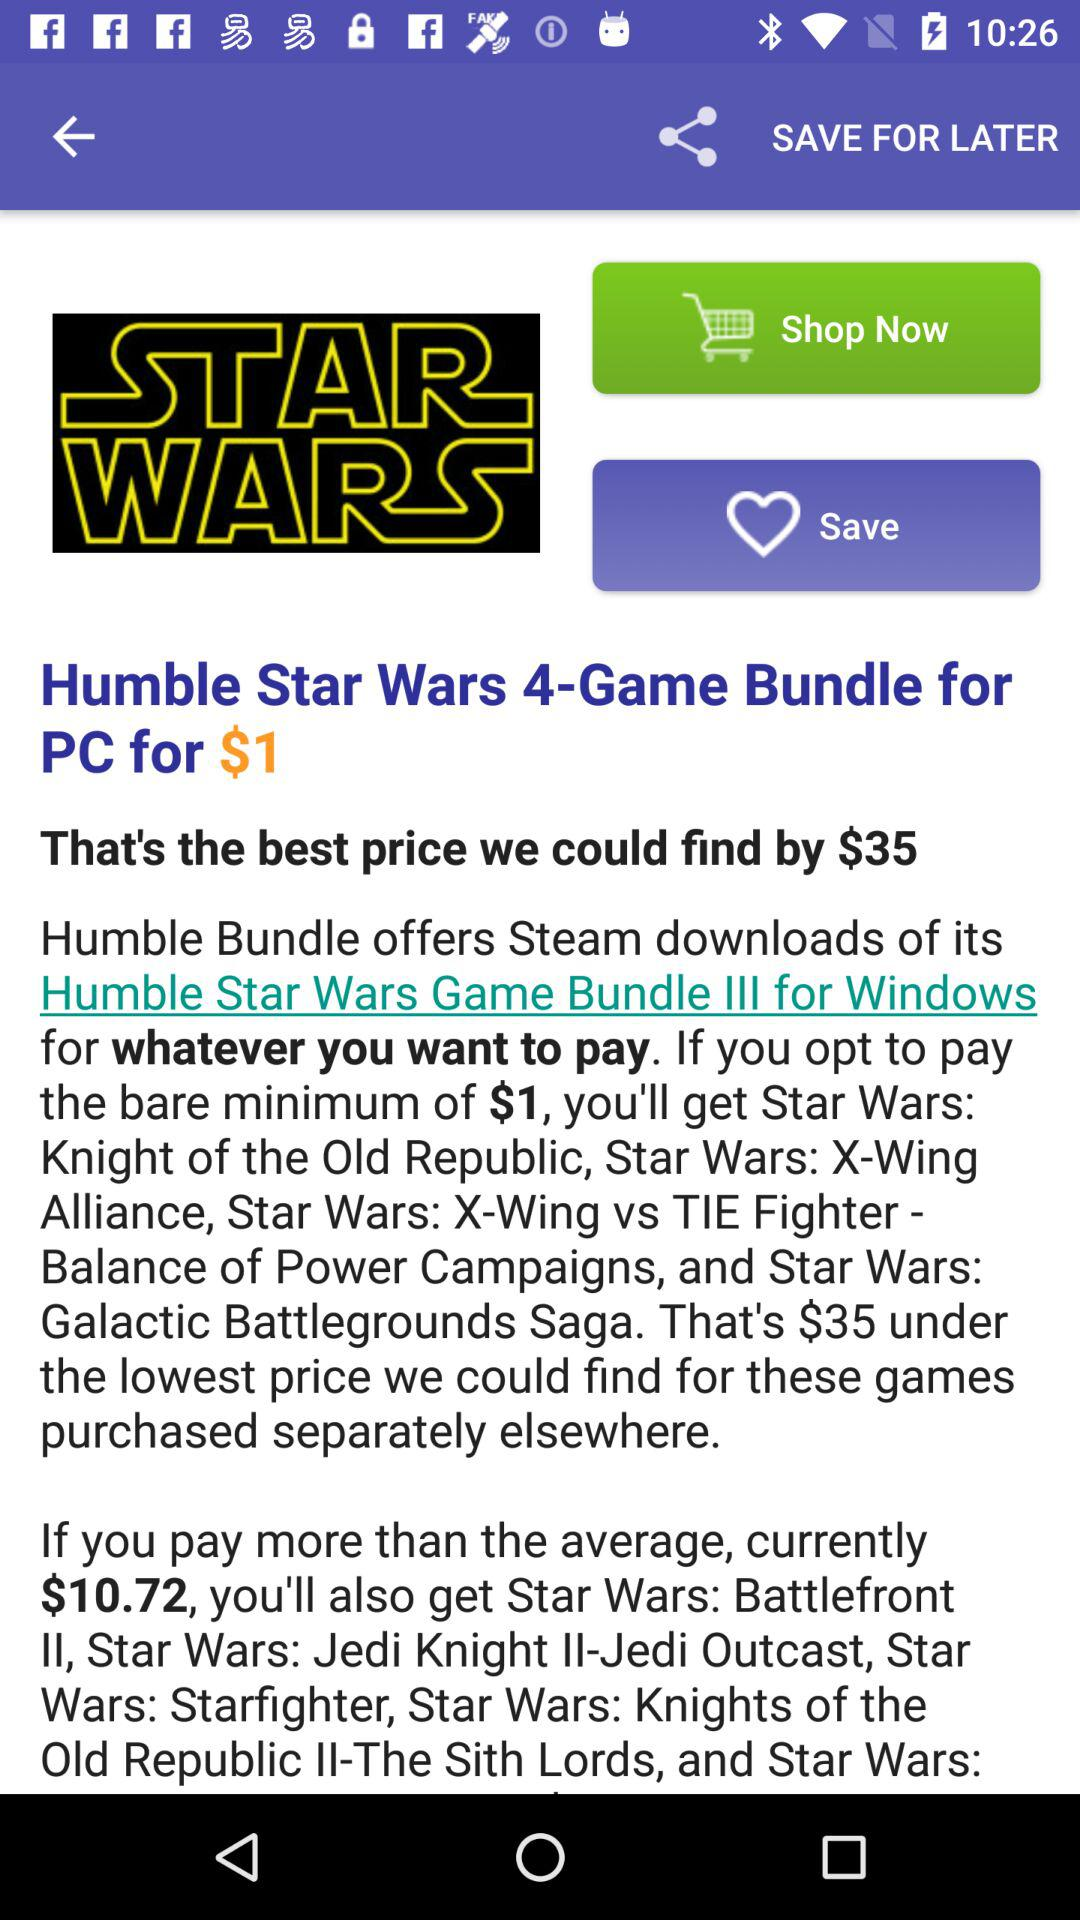What is the price of the "4-Game Bundle"? The price of the "4-Game Bundle" is $1. 